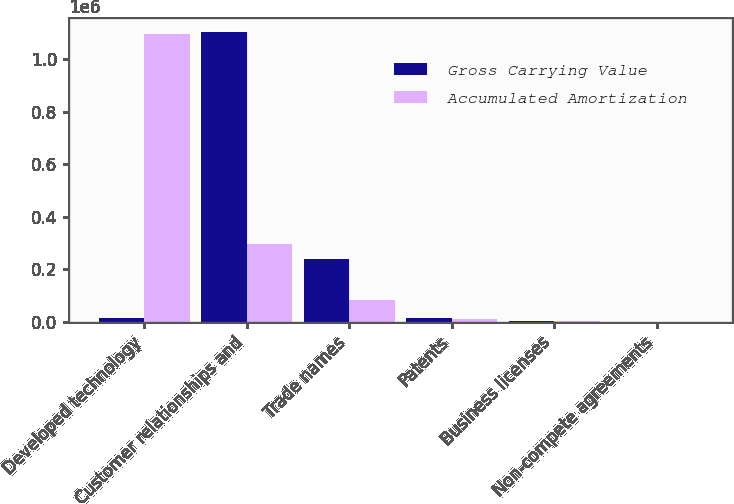<chart> <loc_0><loc_0><loc_500><loc_500><stacked_bar_chart><ecel><fcel>Developed technology<fcel>Customer relationships and<fcel>Trade names<fcel>Patents<fcel>Business licenses<fcel>Non-compete agreements<nl><fcel>Gross Carrying Value<fcel>13026<fcel>1.10187e+06<fcel>238103<fcel>13026<fcel>2647<fcel>296<nl><fcel>Accumulated Amortization<fcel>1.09444e+06<fcel>296481<fcel>81844<fcel>8495<fcel>616<fcel>296<nl></chart> 